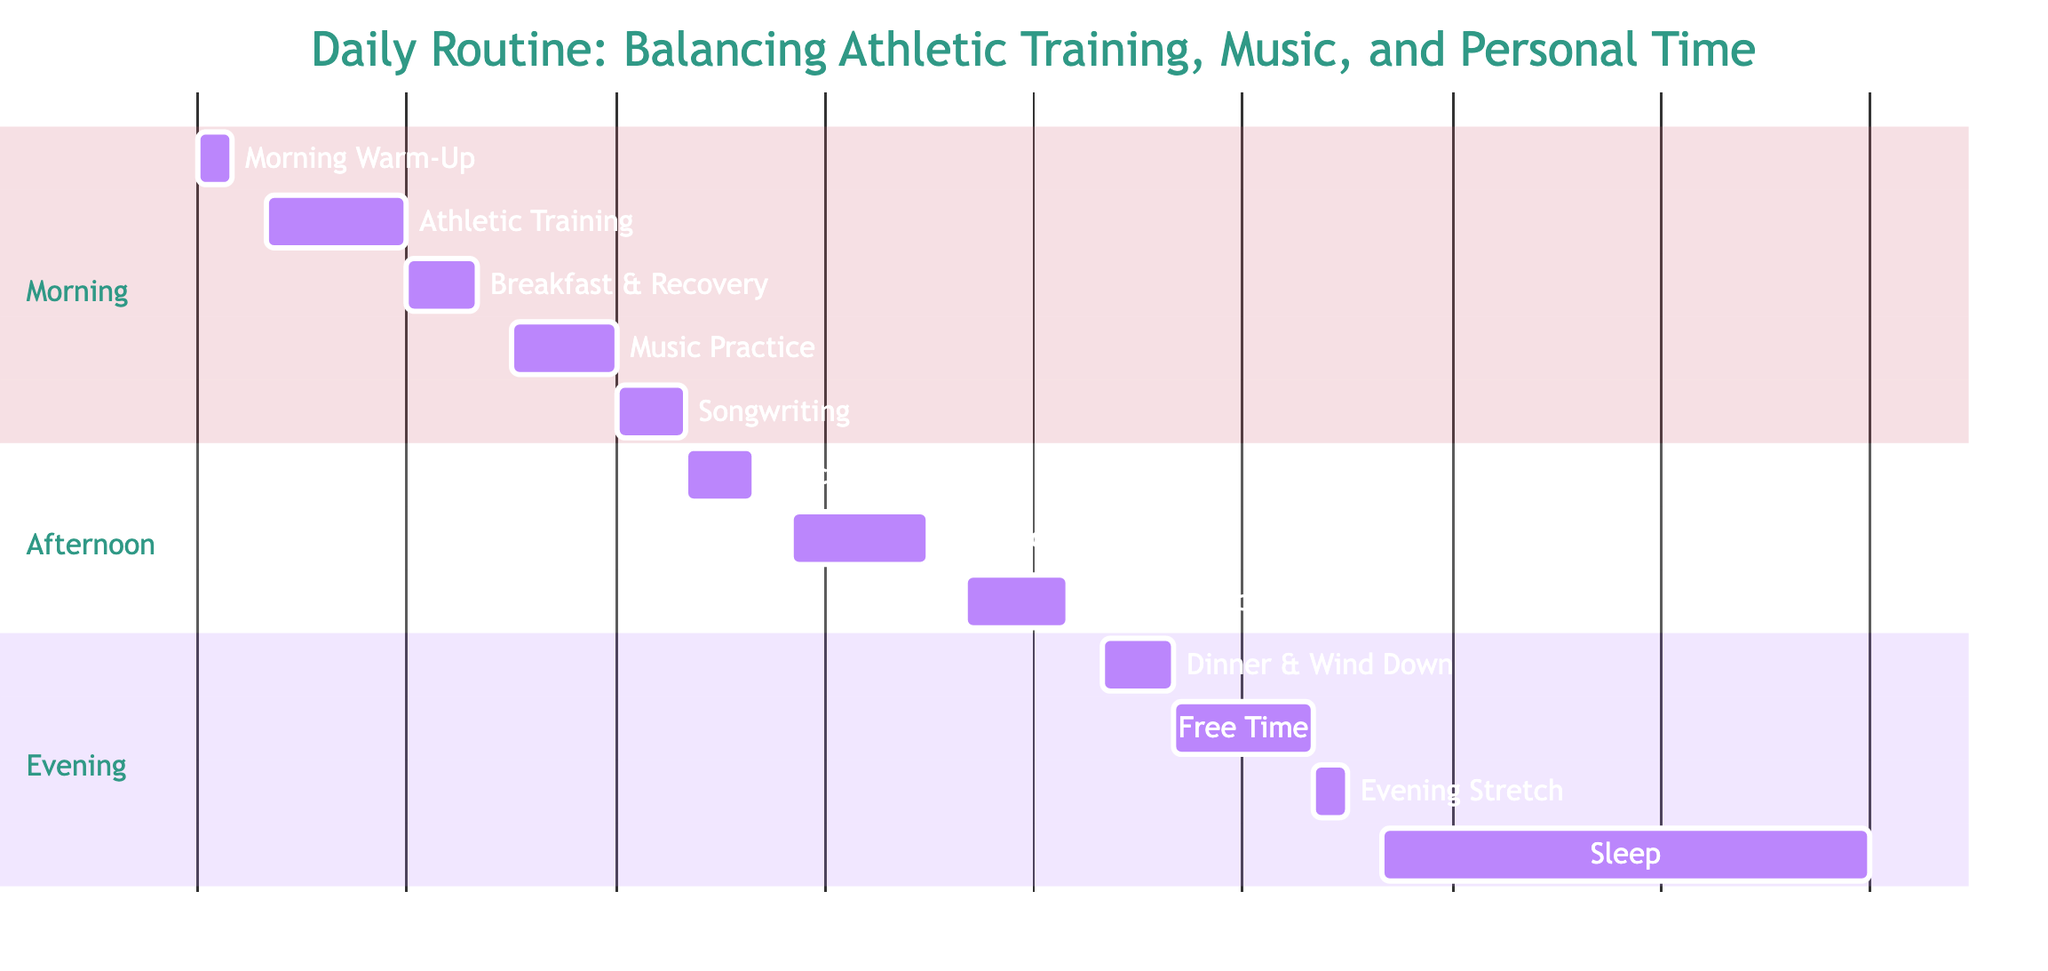What time does the Music Practice session start? The Music Practice session is shown starting from 10:30 in the diagram, as indicated by the starting time on the corresponding bar.
Answer: 10:30 How long is the total time allocated for Athletic Training? There are two Athletic Training sessions in the diagram, one lasting 120 minutes from 7:00 to 9:00 and another one also lasting 120 minutes from 14:30 to 16:30. Adding these together results in a total of 240 minutes.
Answer: 240 minutes What task follows the Songwriting session? The next task after Songwriting is the Lunch and Relaxation session, which starts at 13:00 right after Songwriting ends at 13:00.
Answer: Lunch and Relaxation How many hours are dedicated to Music-related activities? The Music Practice session lasts 90 minutes and the Music Production session lasts 90 minutes. Summing these gives a total of 180 minutes, or 3 hours, allocated to Music-related activities.
Answer: 3 hours What ends the daily routine plan? The last task in the daily routine is Sleep, which starts at 23:00, ending the day with adequate rest.
Answer: Sleep Which task has the shortest duration? The Morning Warm-Up, which lasts for 30 minutes from 6:00 to 6:30, is the shortest duration task in the schedule.
Answer: Morning Warm-Up What are the starting and ending times for Free Time? Free Time starts at 20:00 and ends at 22:00, as displayed on the Gantt chart.
Answer: 20:00 to 22:00 How does the duration of Evening Stretch compare to Morning Warm-Up? The Evening Stretch lasts for 30 minutes, the same duration as the Morning Warm-Up, indicating that they both take the same amount of time.
Answer: Same duration What is the total duration of personal time scheduled in the day? Personal time, including Free Time and Evening Stretch, totals 150 minutes, with Free Time spanning 120 minutes and Evening Stretch covering an additional 30 minutes.
Answer: 150 minutes 